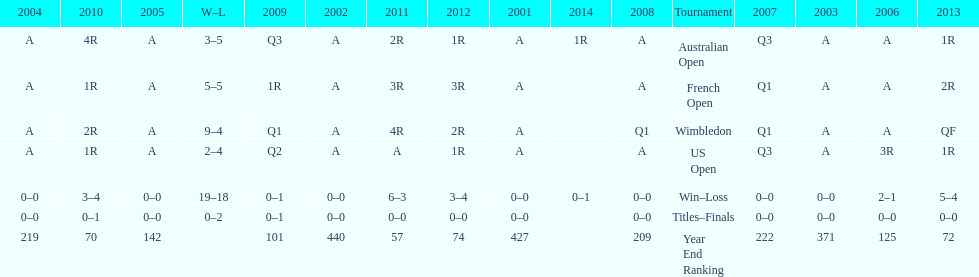In which contest is the "w-l" record 5-5? French Open. 